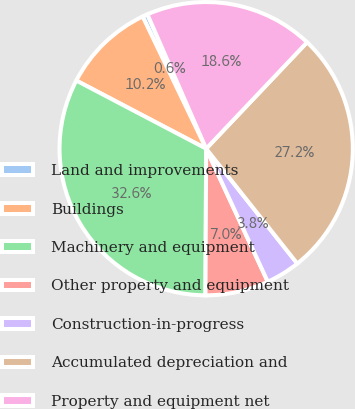Convert chart. <chart><loc_0><loc_0><loc_500><loc_500><pie_chart><fcel>Land and improvements<fcel>Buildings<fcel>Machinery and equipment<fcel>Other property and equipment<fcel>Construction-in-progress<fcel>Accumulated depreciation and<fcel>Property and equipment net<nl><fcel>0.57%<fcel>10.18%<fcel>32.61%<fcel>6.98%<fcel>3.77%<fcel>27.25%<fcel>18.64%<nl></chart> 